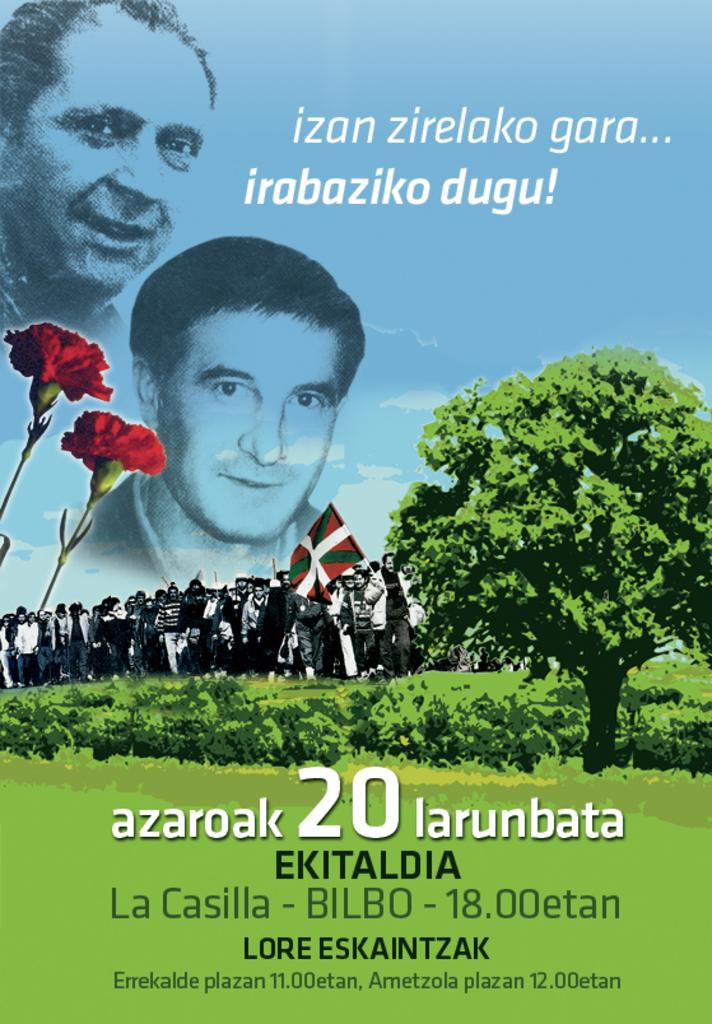<image>
Describe the image concisely. A promotional poster written in a foreign language which reads in part "Ekitaldia". 